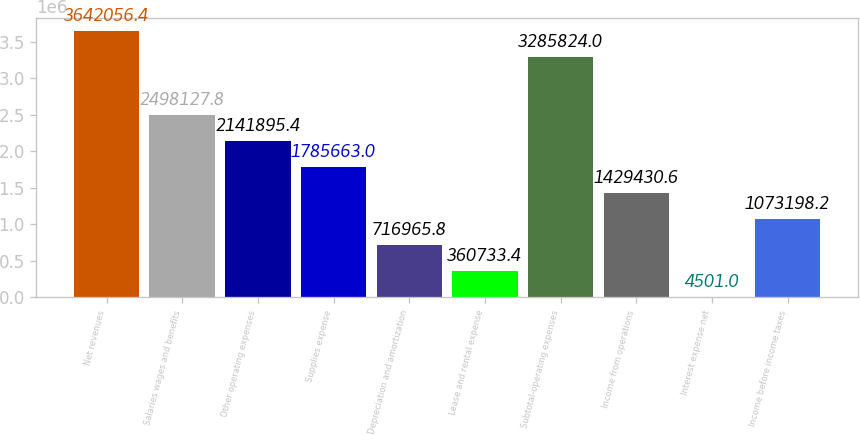Convert chart. <chart><loc_0><loc_0><loc_500><loc_500><bar_chart><fcel>Net revenues<fcel>Salaries wages and benefits<fcel>Other operating expenses<fcel>Supplies expense<fcel>Depreciation and amortization<fcel>Lease and rental expense<fcel>Subtotal-operating expenses<fcel>Income from operations<fcel>Interest expense net<fcel>Income before income taxes<nl><fcel>3.64206e+06<fcel>2.49813e+06<fcel>2.1419e+06<fcel>1.78566e+06<fcel>716966<fcel>360733<fcel>3.28582e+06<fcel>1.42943e+06<fcel>4501<fcel>1.0732e+06<nl></chart> 